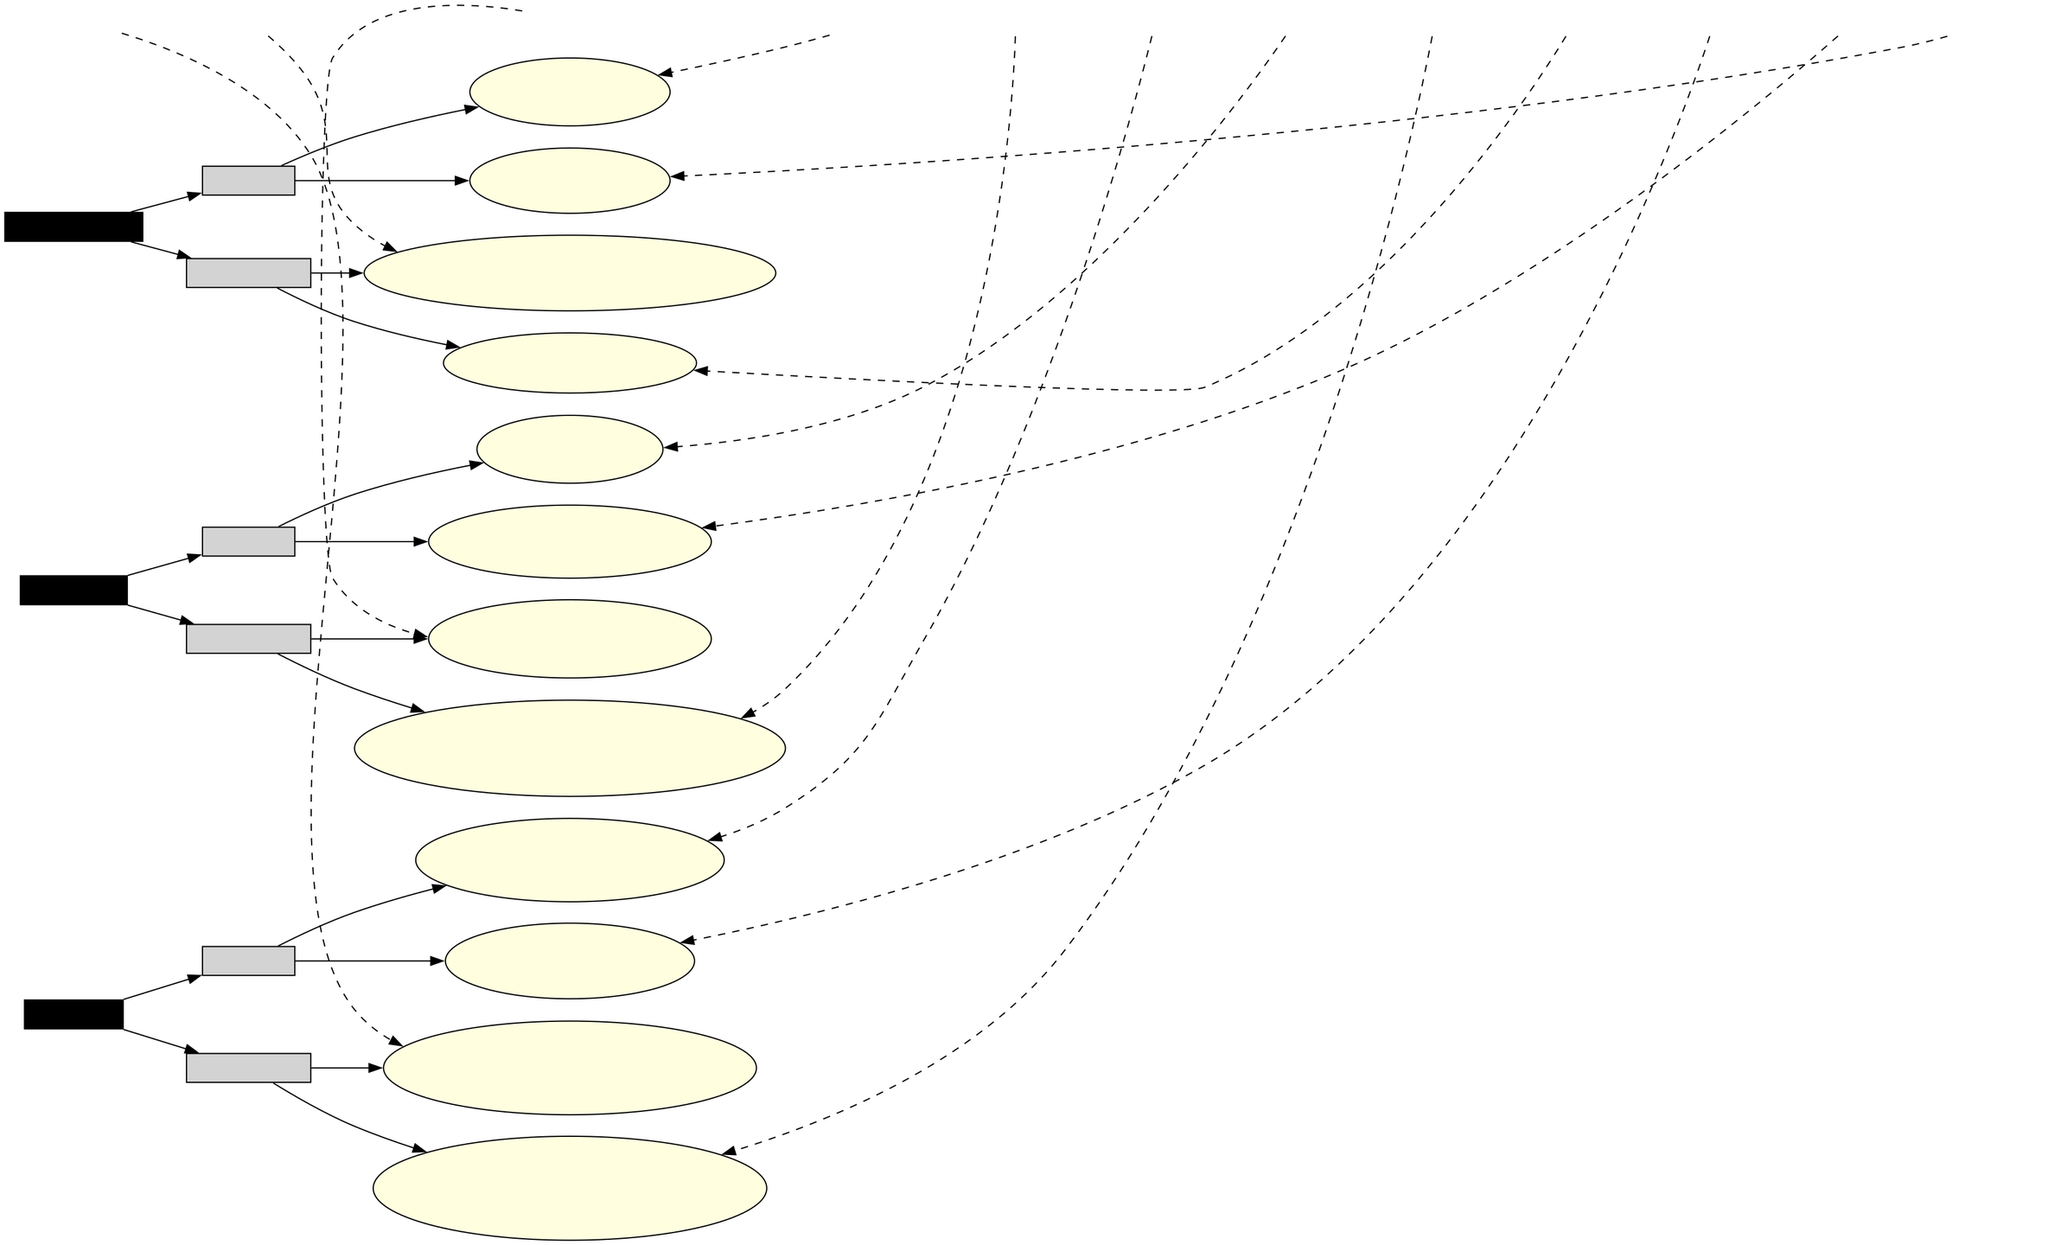What is the most frequently mentioned healthcare issue by Donald Trump? According to the diagram, Donald Trump's most frequently mentioned healthcare issue is related to "COVID-19 Response" on "2020-07-10," with a frequency of 25 times.
Answer: COVID-19 Response Which candidate made statements on immigration more frequently in total? By analyzing the total frequency of statements made by each candidate on immigration, Joe Biden's statements total 16 (7 + 9), while Donald Trump's total is 34 (12 + 22). Therefore, Donald Trump made more frequent statements.
Answer: Donald Trump What date did Joe Biden address the Affordable Care Act? The diagram indicates that Joe Biden addressed the Affordable Care Act on "2021-01-15."
Answer: 2021-01-15 How many statements did Joe Biden make on climate change? The diagram shows that Joe Biden made two statements regarding climate change: one on "2019-06-04" and another on "2021-04-22." Therefore, he made a total of two statements.
Answer: 2 Which category contains the most statements combined for Joe Biden? In examining the statement counts within the diagram, Joe Biden made a total of 27 statements within the healthcare category (15 + 10) compared to 16 in immigration (7 + 9) and 13 in climate change (8 + 5). Hence, healthcare is the category with the most statements.
Answer: Healthcare Who made the earliest statement on climate change? Referring to the timeline, Donald Trump made an earlier statement related to climate change on "2017-06-01," regarding the withdrawal from the Paris Agreement.
Answer: Donald Trump What was the frequency of statements made by Joe Biden regarding DACA? The diagram shows that Joe Biden made statements on the DACA Program with a frequency of 7 times on "2020-06-27."
Answer: 7 Which candidate has addressed the Green New Deal in the timeline? From the timeline, it is evident that Joe Biden has addressed the Green New Deal on "2019-06-04."
Answer: Joe Biden How many total healthcare-related statements did both candidates make on October 2020? Analyzing the diagram, only Donald Trump's statement on "COVID-19 Response" dated "2020-07-10" is relevant since no healthcare-related statements are recorded for Biden after that until 2021. Thus, the total is 25 from Donald Trump.
Answer: 25 